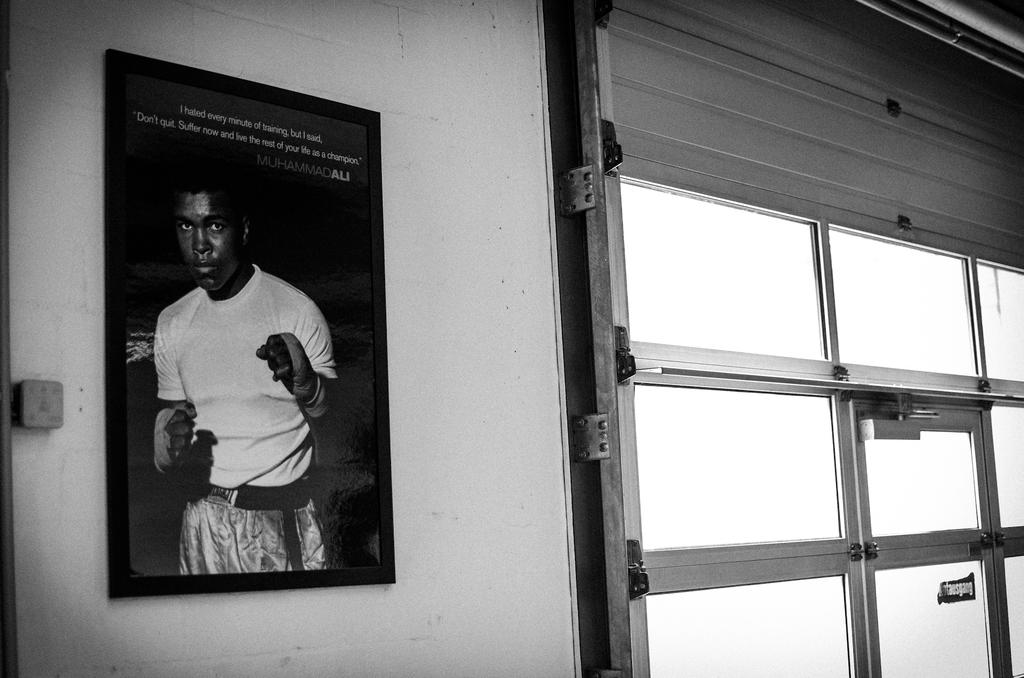What is on the wall in the image? There is a frame on the wall in the image. What material is present in the image that is transparent or translucent? There is glass in the image. What type of mechanism is visible in the image that controls light or visibility? There is a shutter in the image. What long, thin objects can be seen in the image? There are rods in the image. What advertisement can be seen on the wall in the image? There is no advertisement present in the image; it only features a frame, glass, shutter, and rods. How many geese are visible in the image? There are no geese present in the image. 